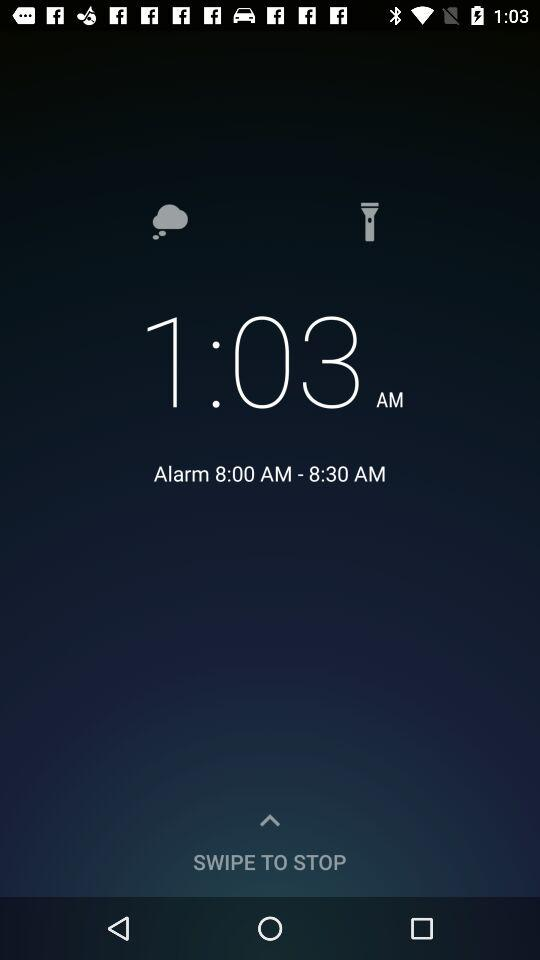How many more minutes until the alarm goes off?
Answer the question using a single word or phrase. 30 